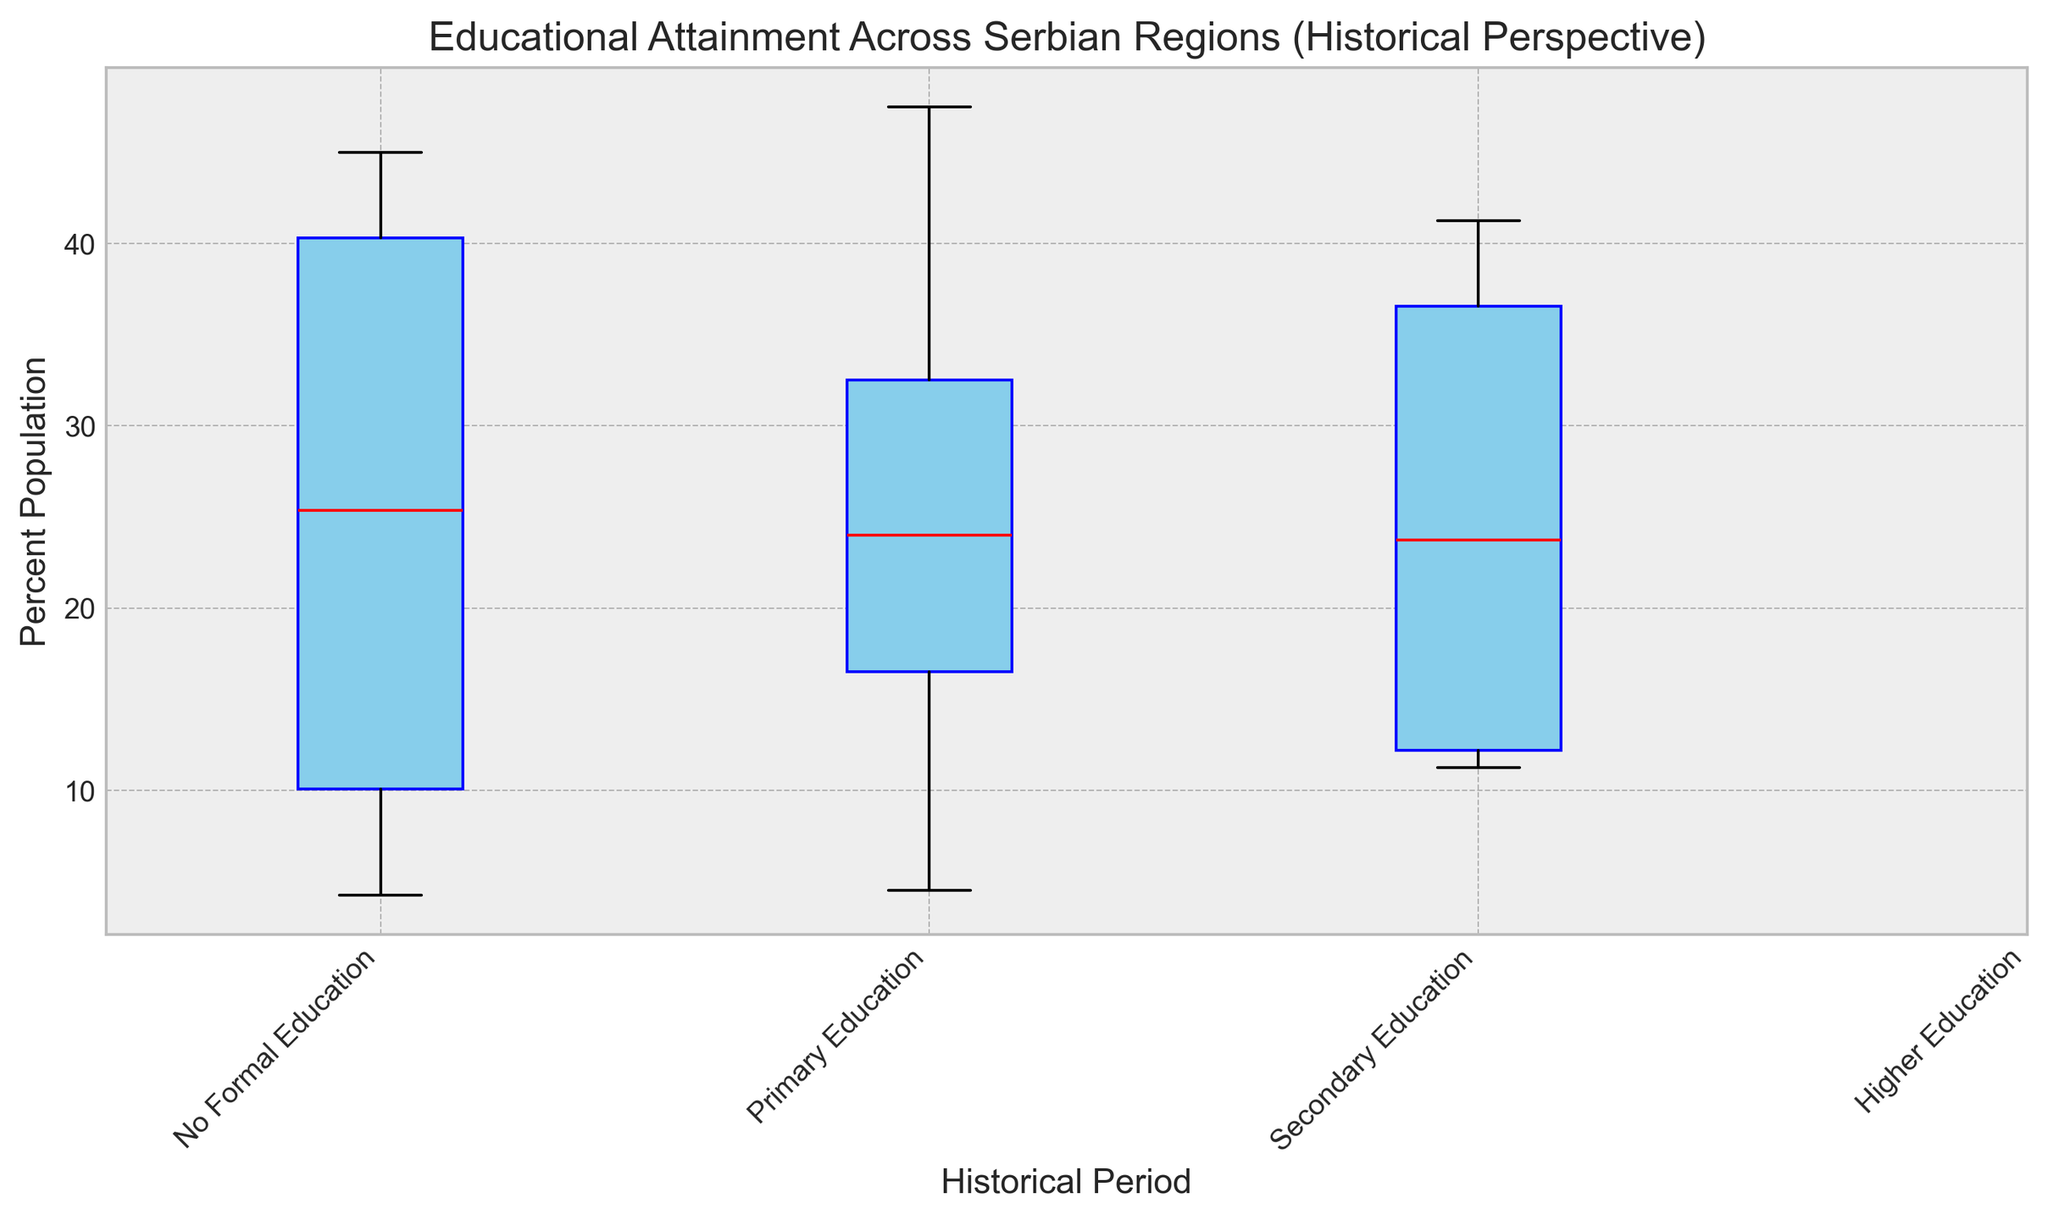Which historical period saw the lowest percentage of the population with no formal education in Belgrade? Examining the box plot for Belgrade across historical periods, identify the one with the lowest box or whisker for "No Formal Education".
Answer: 2000s Which region had the highest percentage of the population with primary education in the 1900s? Compare the values for "Primary Education" in the 1900s for all listed regions. The highest value will indicate the region with the maximum percentage for that period.
Answer: Vojvodina What is the median percentage of the population with secondary education in the 2000s across all regions? Observe the middle value (median) of the box plot for "Secondary Education" in the 2000s, which is represented typically by a red line in the middle of the box.
Answer: 40% How did higher education levels change in Southern Serbia from the 1900s to the 2000s? Compare the box heights for "Higher Education" in Southern Serbia from the 1900s to the 2000s to observe the change. The 2000s should show a higher value.
Answer: Increased Which region shows the most significant improvement in educational attainment from the 1900s to the 2000s? Compare the overall heights and medians for different educational levels from the 1900s to the 2000s across all regions. Identify the region with the most considerable reduction in "No Formal Education" and increase in "Secondary" and "Higher Education".
Answer: Belgrade Between Belgrade and Sumadija in the 1950s, which region had a higher percentage of the population with no formal education? Directly compare the box plot values for "No Formal Education" between Belgrade and Sumadija in the 1950s.
Answer: Sumadija What is the difference in median percentages of higher education attainment between Belgrade and Vojvodina in the 2000s? Find and compare the median percentages of the "Higher Education" category in the 2000s for both Belgrade and Vojvodina. Calculate the difference between the two median values.
Answer: 5% If one were to rank the regions by the highest median educational attainment in the 2000s, which region would come first? Compare the median values of educational attainment categories like "Secondary" and "Higher Education" for all regions in the 2000s. The region with the overall highest median values ranks first.
Answer: Belgrade What is the visual trend for changes in primary education levels from the 1900s to the 2000s across all regions? Observe the box plot for "Primary Education" across all historical periods and note the general direction of the change in the box heights. A decreasing trend will be noted.
Answer: Decreasing 